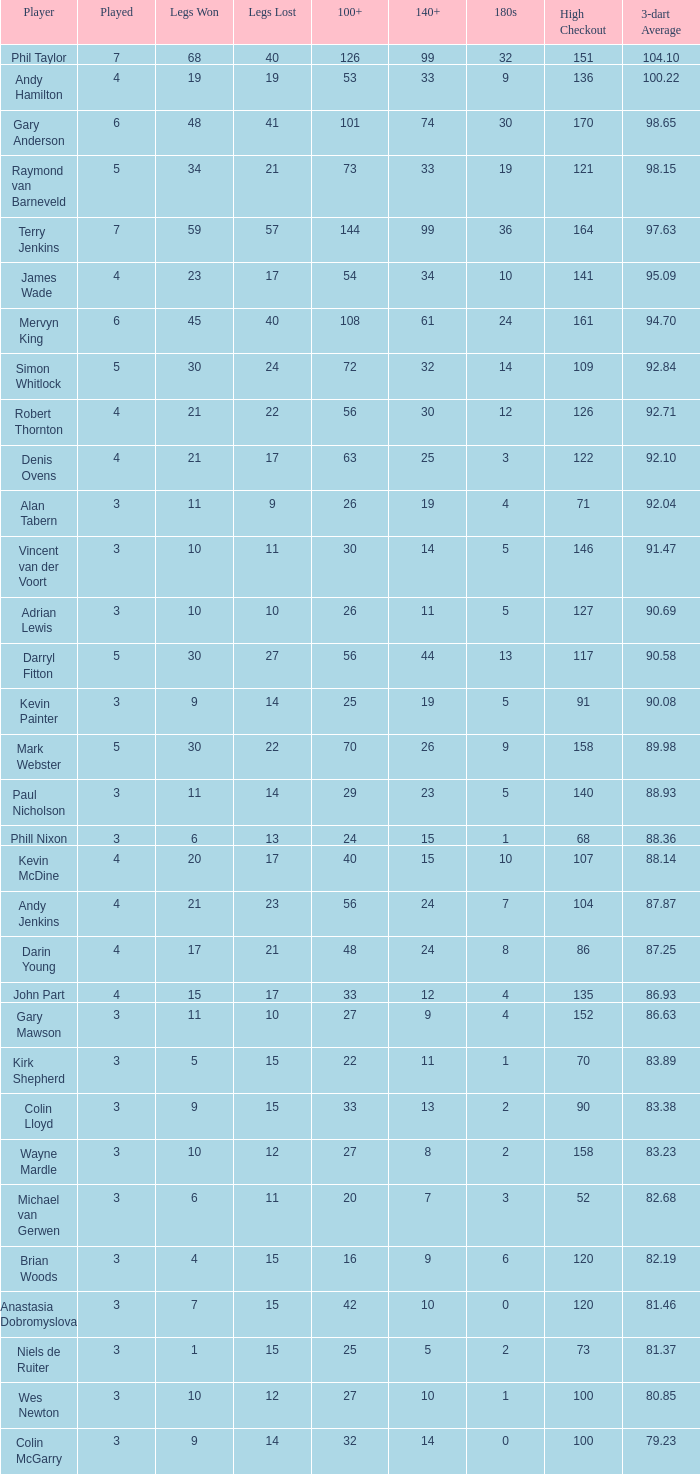What is the number of high checkout when legs Lost is 17, 140+ is 15, and played is larger than 4? None. 